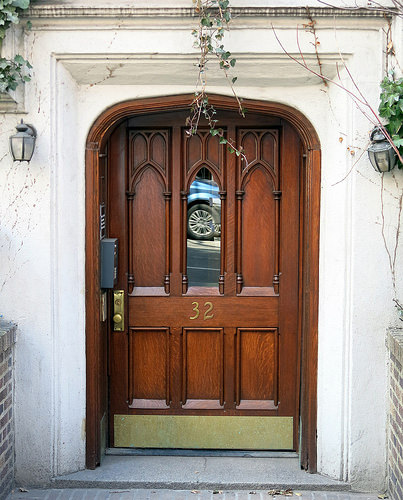<image>
Can you confirm if the light is in front of the door? No. The light is not in front of the door. The spatial positioning shows a different relationship between these objects. 